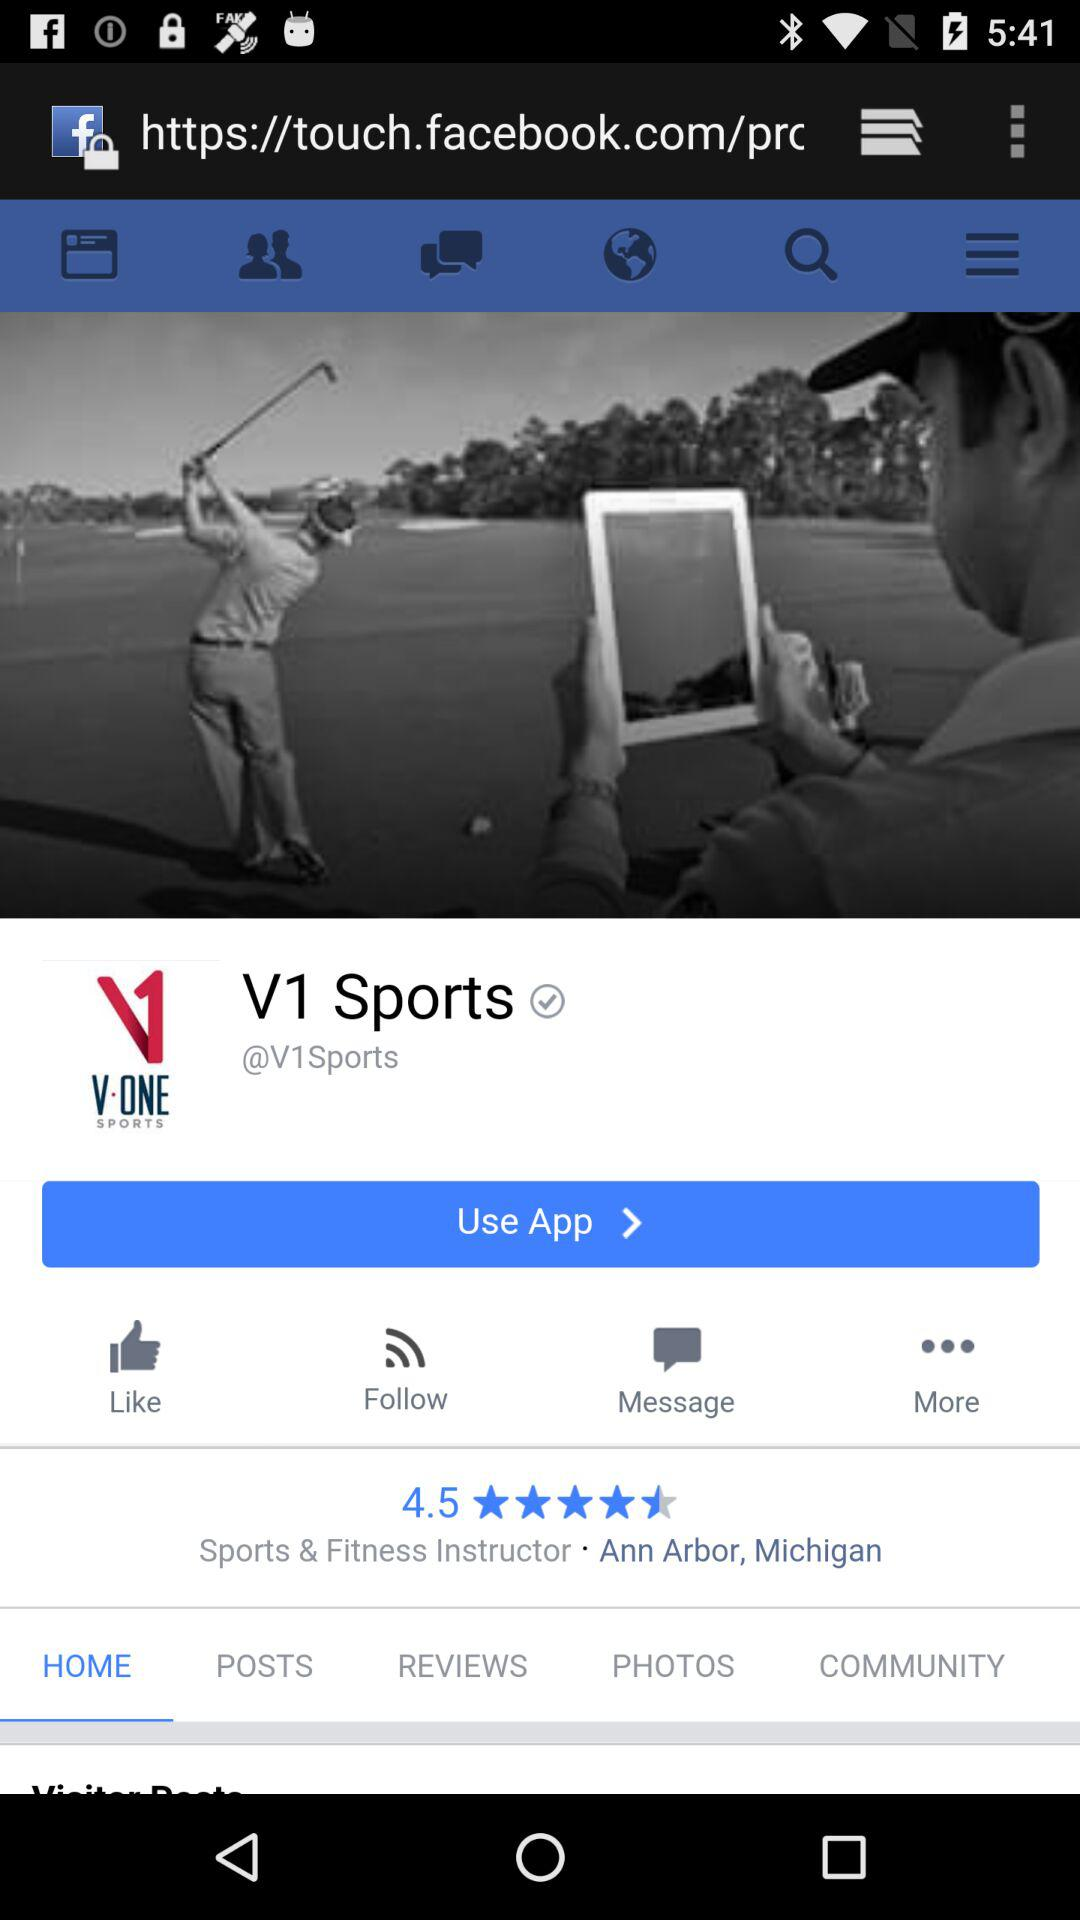What is the mentioned location? The mentioned location is Ann Arbor, Michigan. 